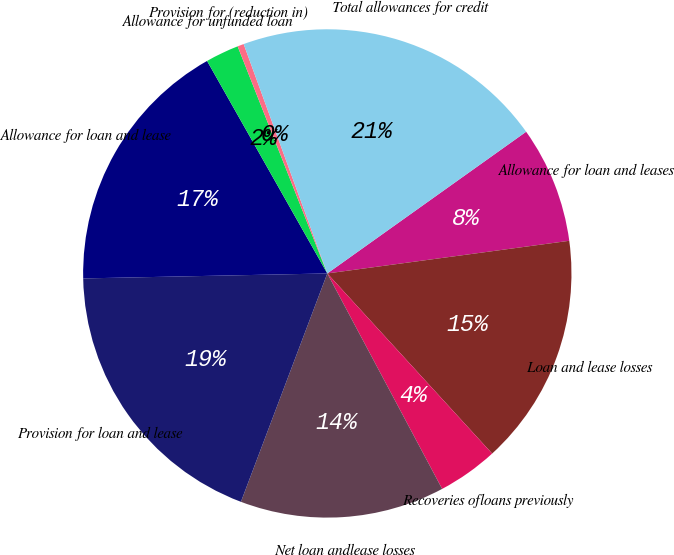Convert chart to OTSL. <chart><loc_0><loc_0><loc_500><loc_500><pie_chart><fcel>Allowance for loan and leases<fcel>Loan and lease losses<fcel>Recoveries ofloans previously<fcel>Net loan andlease losses<fcel>Provision for loan and lease<fcel>Allowance for loan and lease<fcel>Allowance for unfunded loan<fcel>Provision for (reduction in)<fcel>Total allowances for credit<nl><fcel>7.72%<fcel>15.34%<fcel>4.0%<fcel>13.55%<fcel>18.92%<fcel>17.13%<fcel>2.21%<fcel>0.42%<fcel>20.71%<nl></chart> 